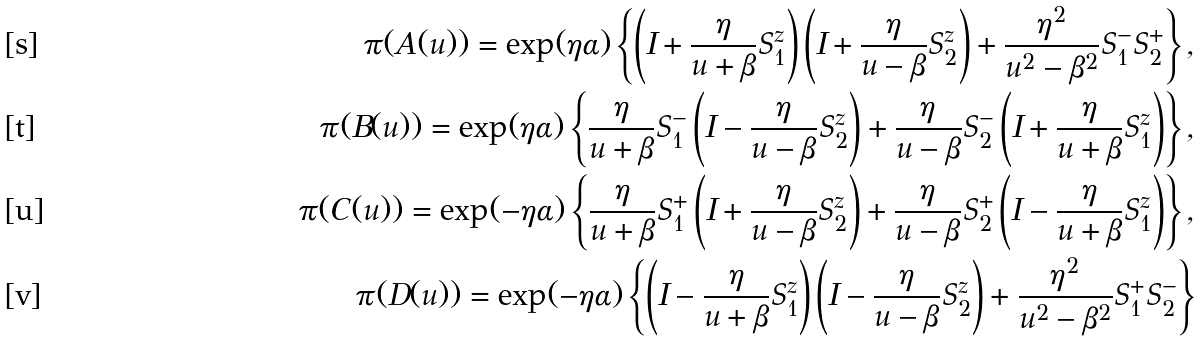Convert formula to latex. <formula><loc_0><loc_0><loc_500><loc_500>\pi ( A ( u ) ) = \exp ( \eta \alpha ) \left \{ \left ( I + \frac { \eta } { u + \beta } S ^ { z } _ { 1 } \right ) \left ( I + \frac { \eta } { u - \beta } S ^ { z } _ { 2 } \right ) + \frac { \eta ^ { 2 } } { u ^ { 2 } - \beta ^ { 2 } } S ^ { - } _ { 1 } S ^ { + } _ { 2 } \right \} , \\ \pi ( B ( u ) ) = \exp ( \eta \alpha ) \left \{ \frac { \eta } { u + \beta } S ^ { - } _ { 1 } \left ( I - \frac { \eta } { u - \beta } S ^ { z } _ { 2 } \right ) + \frac { \eta } { u - \beta } S ^ { - } _ { 2 } \left ( I + \frac { \eta } { u + \beta } S ^ { z } _ { 1 } \right ) \right \} , \\ \pi ( C ( u ) ) = \exp ( - \eta \alpha ) \left \{ \frac { \eta } { u + \beta } S ^ { + } _ { 1 } \left ( I + \frac { \eta } { u - \beta } S ^ { z } _ { 2 } \right ) + \frac { \eta } { u - \beta } S ^ { + } _ { 2 } \left ( I - \frac { \eta } { u + \beta } S ^ { z } _ { 1 } \right ) \right \} , \\ \pi ( D ( u ) ) = \exp ( - \eta \alpha ) \left \{ \left ( I - \frac { \eta } { u + \beta } S ^ { z } _ { 1 } \right ) \left ( I - \frac { \eta } { u - \beta } S ^ { z } _ { 2 } \right ) + \frac { \eta ^ { 2 } } { u ^ { 2 } - \beta ^ { 2 } } S ^ { + } _ { 1 } S ^ { - } _ { 2 } \right \}</formula> 